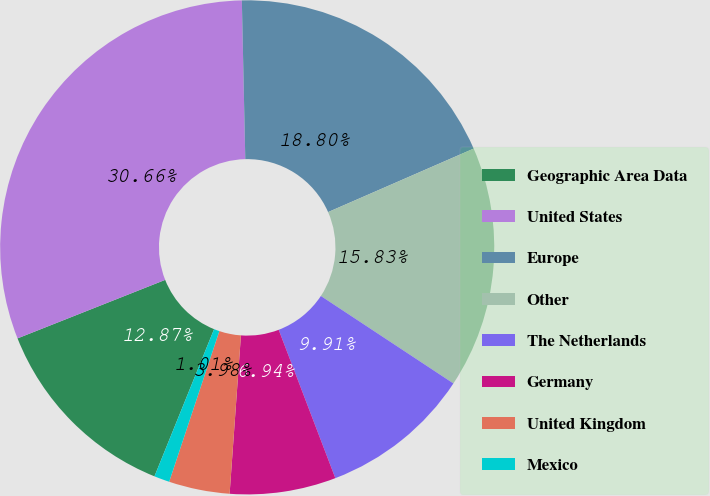Convert chart to OTSL. <chart><loc_0><loc_0><loc_500><loc_500><pie_chart><fcel>Geographic Area Data<fcel>United States<fcel>Europe<fcel>Other<fcel>The Netherlands<fcel>Germany<fcel>United Kingdom<fcel>Mexico<nl><fcel>12.87%<fcel>30.66%<fcel>18.8%<fcel>15.83%<fcel>9.91%<fcel>6.94%<fcel>3.98%<fcel>1.01%<nl></chart> 